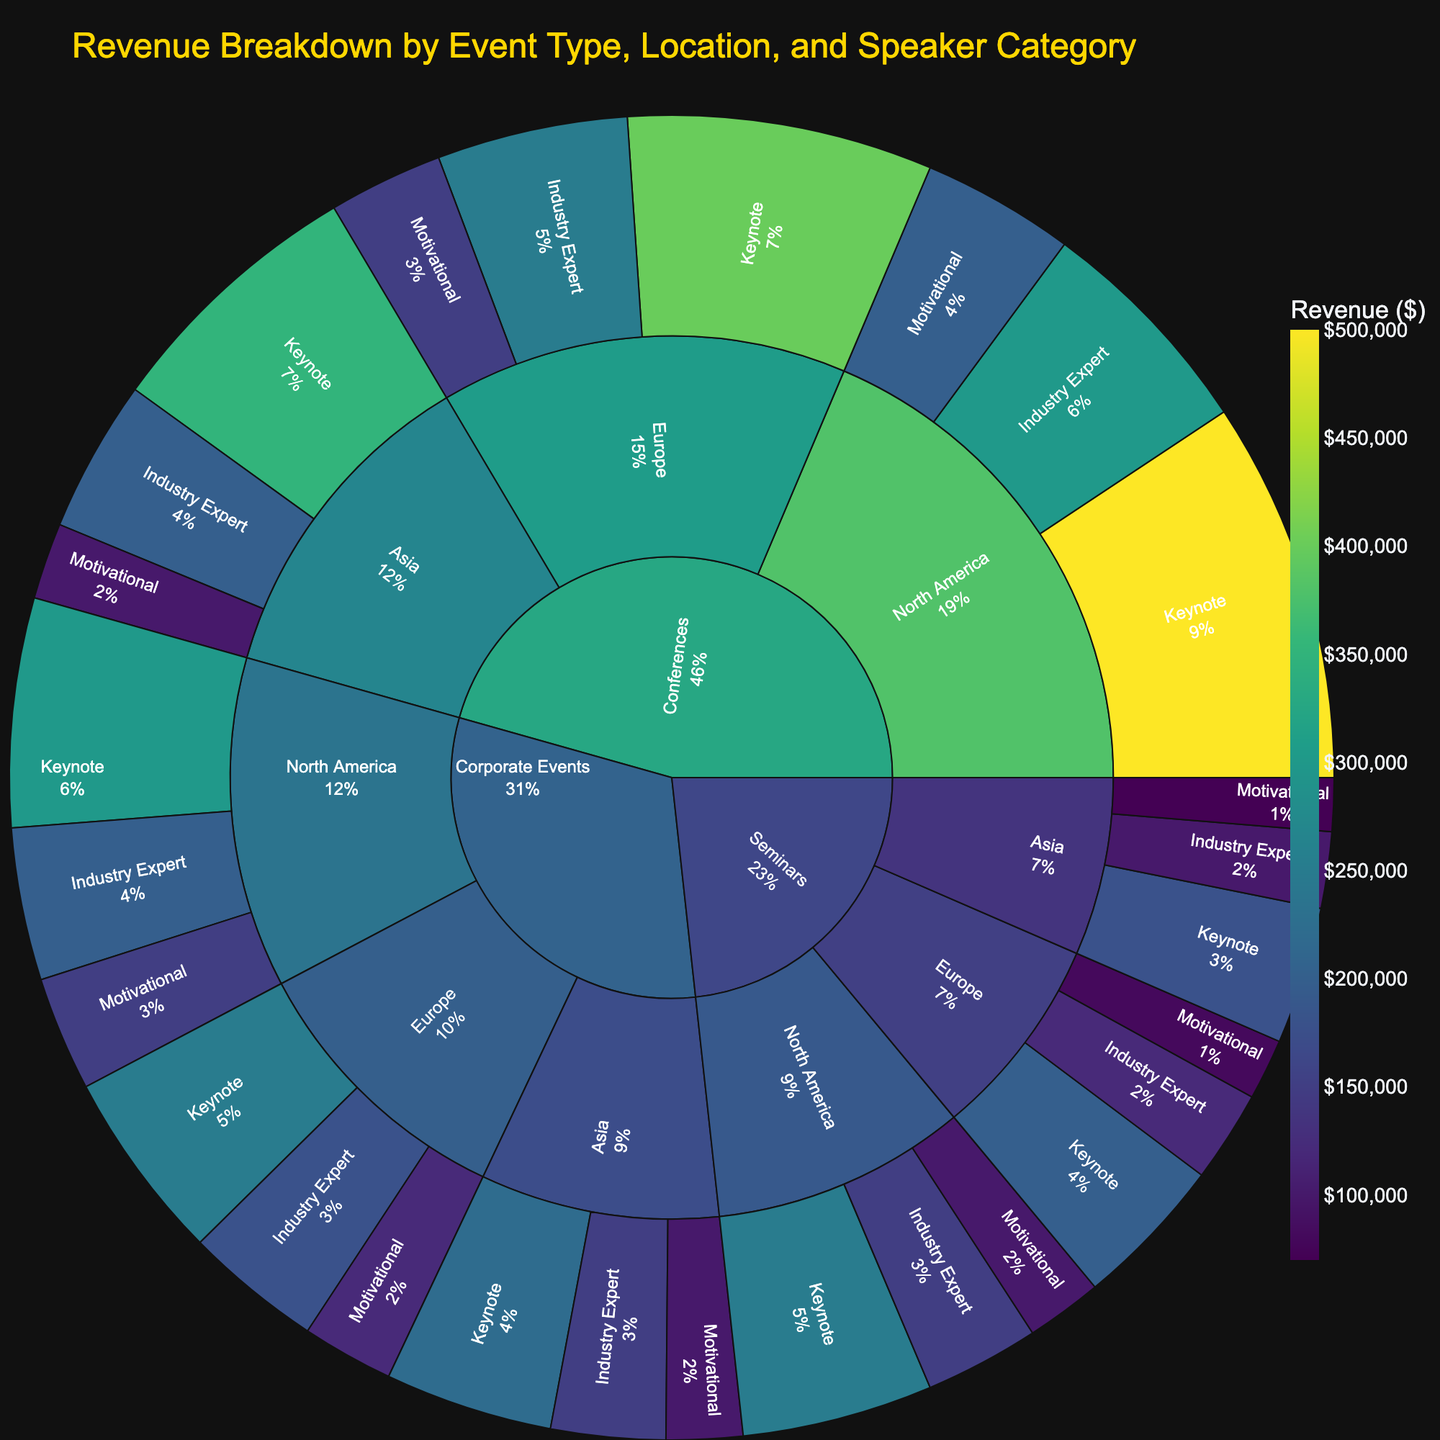What is the event type with the highest revenue? The largest segment in the sunburst plot represents the event type with the highest revenue. By examining the segments, it is clear that the "Conferences" segment occupies the largest area.
Answer: Conferences Which location generates the most revenue for Keynote speakers? By looking at the segments for Keynote speakers within each location, we can compare their sizes. The North America segment for Keynote speakers is the largest.
Answer: North America What is the total revenue generated by Motivational speakers across all event types and locations? Sum the revenue for Motivational speakers across all event types and locations: (200000 + 150000 + 100000) + (100000 + 80000 + 70000) + (150000 + 120000 + 100000) = 1070000
Answer: 1,070,000 Which speaker category brings in the least revenue for Seminars in Europe? Within the Seminars segment in Europe, compare the sizes of Keynote, Industry Expert, and Motivational segments. The Motivational segment is the smallest.
Answer: Motivational Is the revenue for Industry Experts in Asia higher or lower than that for Motivational speakers in North America? The revenue for Industry Experts in Asia is 200000, and for Motivational speakers in North America, it is 200000. Compare these values.
Answer: Equal How does the revenue from Corporate Events in Europe compare to Corporate Events in North America for Keynote speakers? Compare the segments for Keynote speakers in Corporate Events between Europe and North America: 250000 (Europe) vs. 300000 (North America).
Answer: North America is higher What percentage of the total revenue comes from Conferences in Asia? Sum the total revenue and the revenue from Conferences in Asia, then calculate the percentage: (350000 + 200000 + 100000) / 4740000 * 100 = 13.24% (rounded)
Answer: 13.24% Which speaker category has the most consistent revenue across all locations for Seminars? Analyze the size of the segments for each speaker category in Seminars across North America, Europe, and Asia. The Keynote segment appears to be the most consistent in size.
Answer: Keynote 